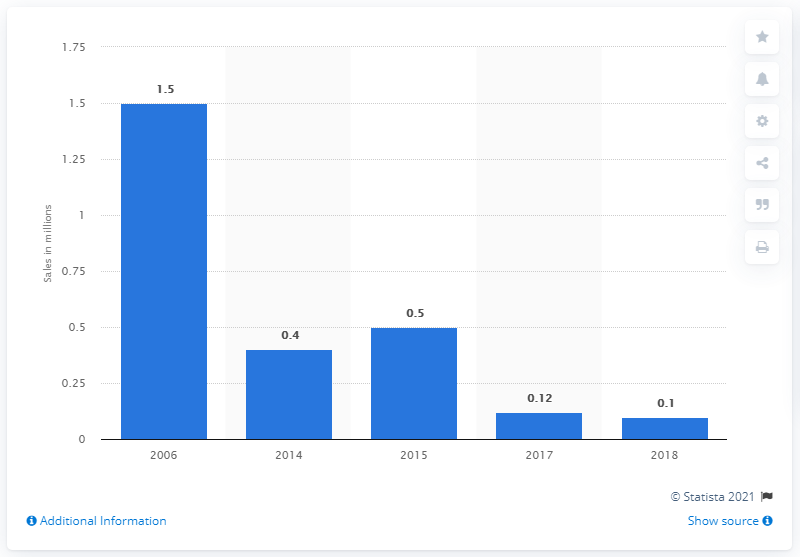Highlight a few significant elements in this photo. In 2006, the sales volume of motorcycles in Iran was approximately 1.5 million units. 